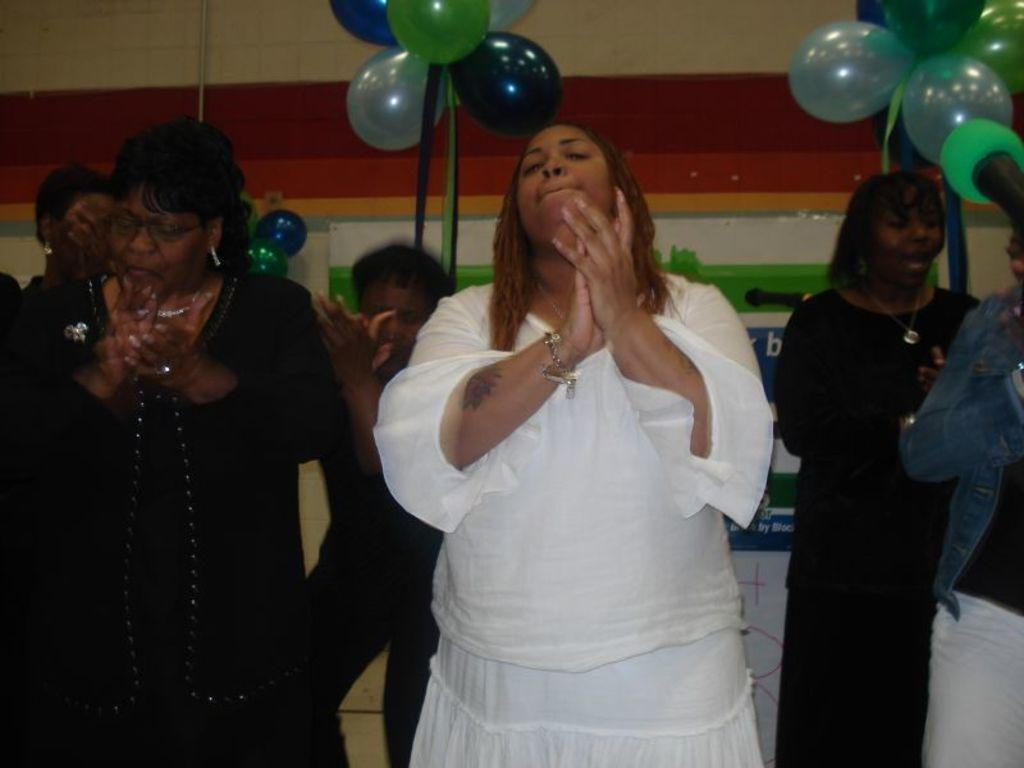What are the two women in the foreground of the picture doing? The two women in the foreground of the picture are clapping. Can you describe the actions of the people in the background of the picture? The people in the background of the picture are also clapping. What decorative items can be seen in the image? There are balloons and ribbons visible in the image. What is attached to the wall in the background of the image? There are posters sticked to the wall in the background of the image. What type of yam is being served at the event in the image? There is no yam present in the image, nor is there any indication of an event taking place. How many people are surprised in the image? There is no indication of surprise or any surprised individuals in the image. 